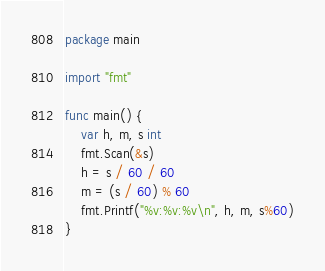<code> <loc_0><loc_0><loc_500><loc_500><_Go_>package main

import "fmt"

func main() {
	var h, m, s int
	fmt.Scan(&s)
	h = s / 60 / 60
	m = (s / 60) % 60
	fmt.Printf("%v:%v:%v\n", h, m, s%60)
}

</code> 